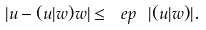<formula> <loc_0><loc_0><loc_500><loc_500>| u - ( u | w ) w | \leq { \ e p } \ | ( u | w ) | .</formula> 